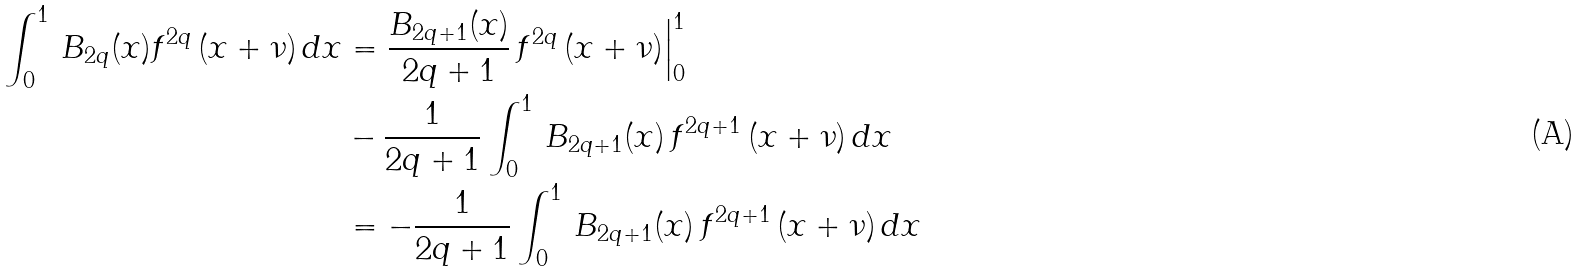Convert formula to latex. <formula><loc_0><loc_0><loc_500><loc_500>\int _ { 0 } ^ { 1 } \, B _ { 2 q } ( x ) f ^ { 2 q } \, ( x + \nu ) \, d x & = \frac { B _ { 2 q + 1 } ( x ) } { 2 q + 1 } \, f ^ { 2 q } \, ( x + \nu ) \Big | _ { 0 } ^ { 1 } \\ & - \frac { 1 } { 2 q + 1 } \int _ { 0 } ^ { 1 } \, B _ { 2 q + 1 } ( x ) \, f ^ { 2 q + 1 } \, ( x + \nu ) \, d x \\ & = - \frac { 1 } { 2 q + 1 } \int _ { 0 } ^ { 1 } \, B _ { 2 q + 1 } ( x ) \, f ^ { 2 q + 1 } \, ( x + \nu ) \, d x</formula> 